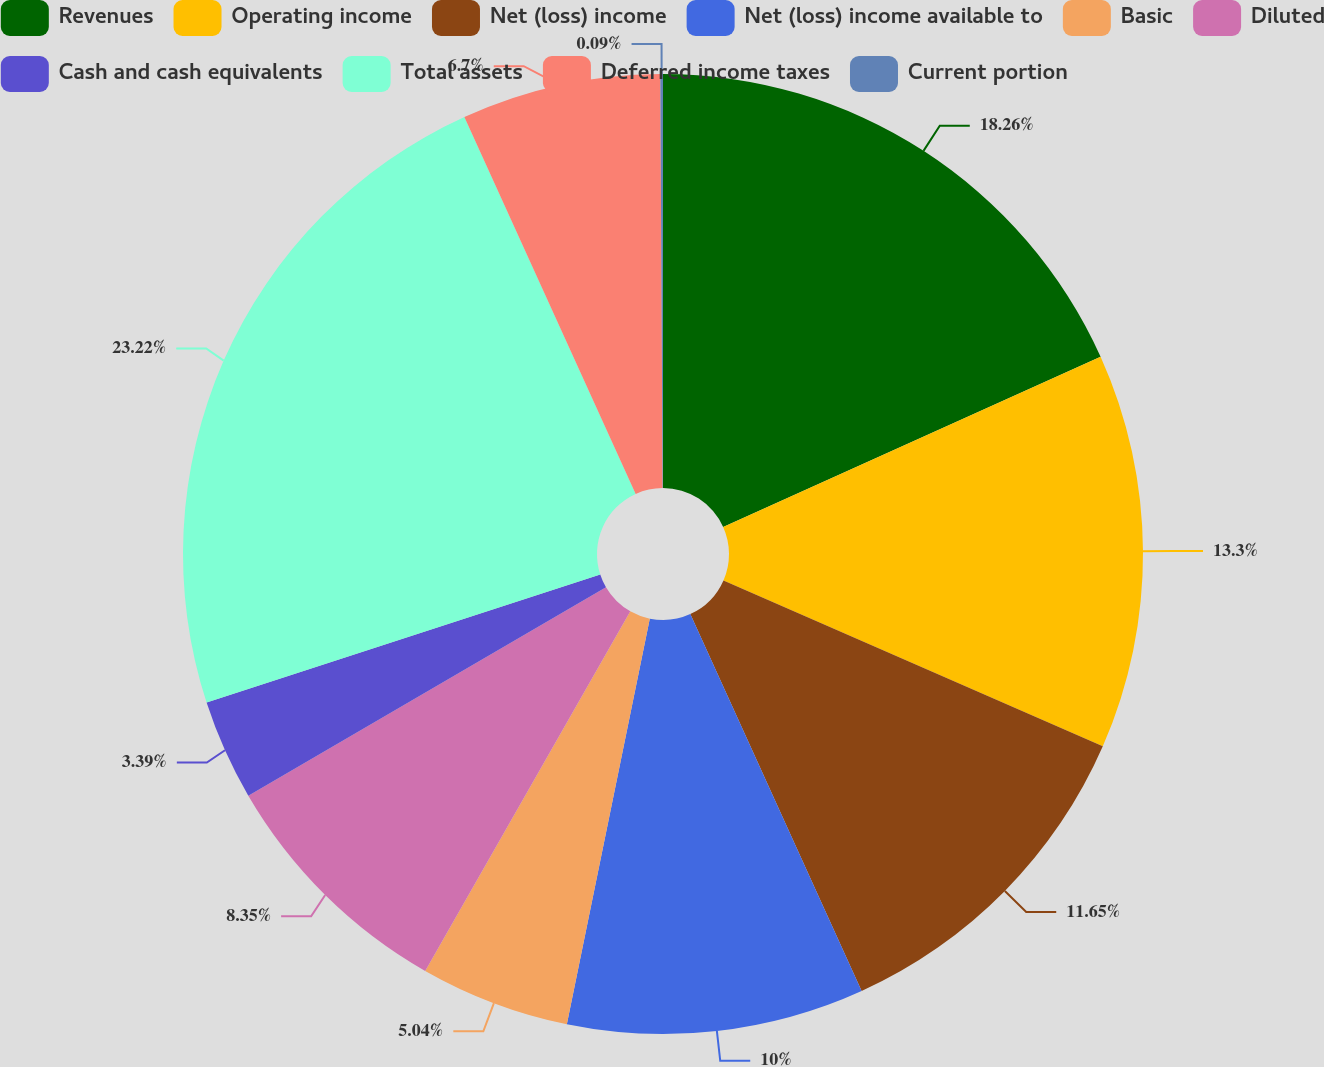<chart> <loc_0><loc_0><loc_500><loc_500><pie_chart><fcel>Revenues<fcel>Operating income<fcel>Net (loss) income<fcel>Net (loss) income available to<fcel>Basic<fcel>Diluted<fcel>Cash and cash equivalents<fcel>Total assets<fcel>Deferred income taxes<fcel>Current portion<nl><fcel>18.26%<fcel>13.3%<fcel>11.65%<fcel>10.0%<fcel>5.04%<fcel>8.35%<fcel>3.39%<fcel>23.22%<fcel>6.7%<fcel>0.09%<nl></chart> 